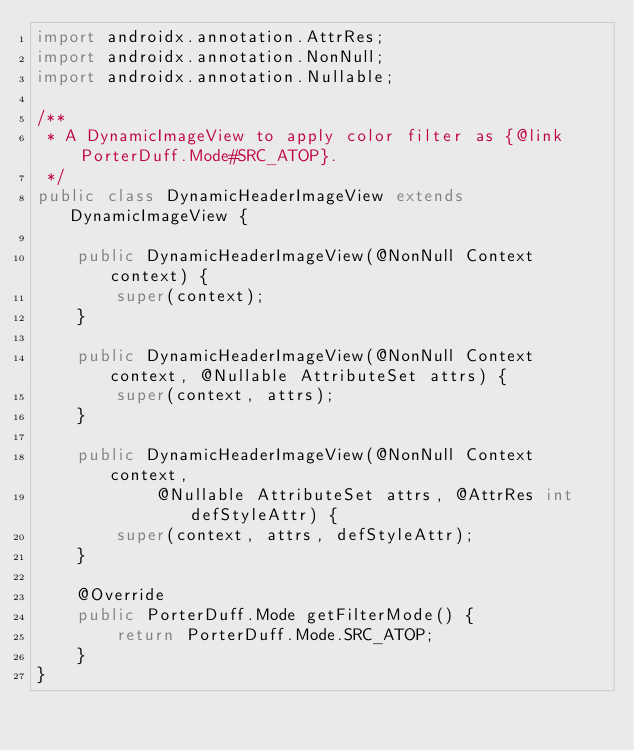<code> <loc_0><loc_0><loc_500><loc_500><_Java_>import androidx.annotation.AttrRes;
import androidx.annotation.NonNull;
import androidx.annotation.Nullable;

/**
 * A DynamicImageView to apply color filter as {@link PorterDuff.Mode#SRC_ATOP}.
 */
public class DynamicHeaderImageView extends DynamicImageView {

    public DynamicHeaderImageView(@NonNull Context context) {
        super(context);
    }

    public DynamicHeaderImageView(@NonNull Context context, @Nullable AttributeSet attrs) {
        super(context, attrs);
    }

    public DynamicHeaderImageView(@NonNull Context context,
            @Nullable AttributeSet attrs, @AttrRes int defStyleAttr) {
        super(context, attrs, defStyleAttr);
    }

    @Override
    public PorterDuff.Mode getFilterMode() {
        return PorterDuff.Mode.SRC_ATOP;
    }
}
</code> 